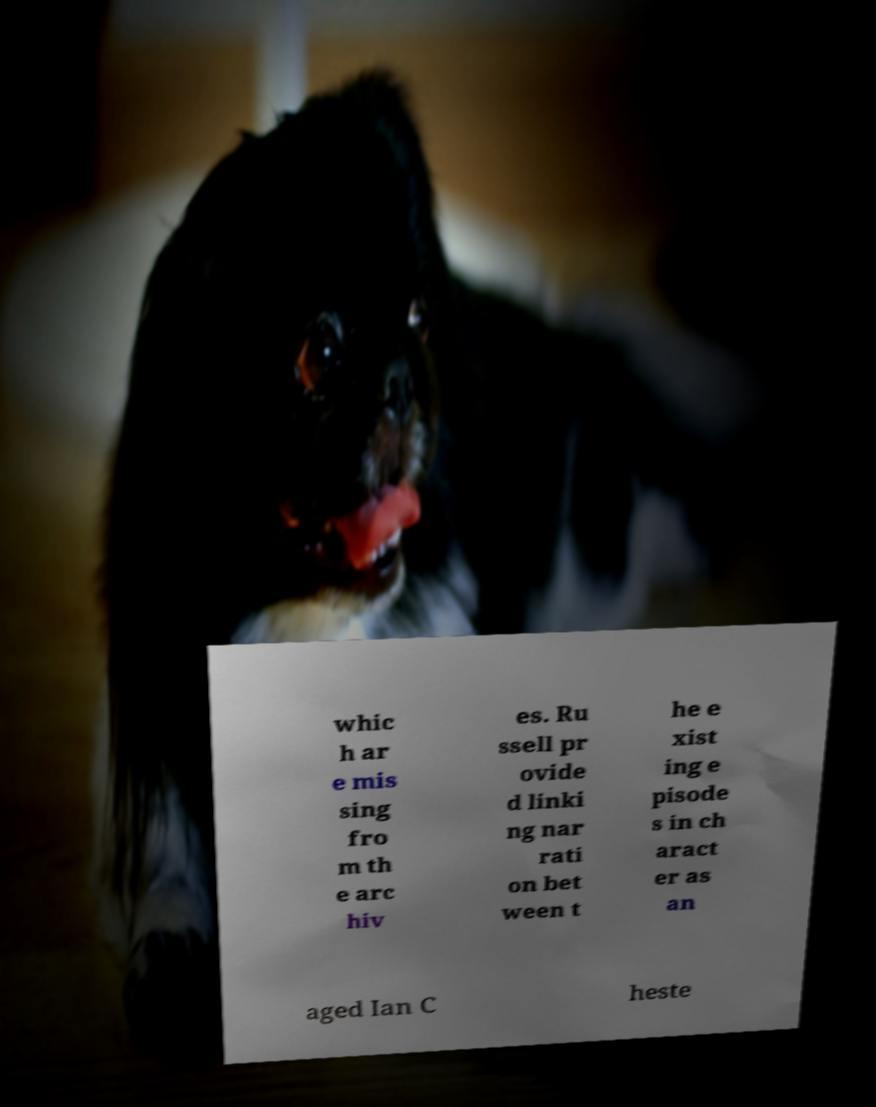Can you accurately transcribe the text from the provided image for me? whic h ar e mis sing fro m th e arc hiv es. Ru ssell pr ovide d linki ng nar rati on bet ween t he e xist ing e pisode s in ch aract er as an aged Ian C heste 